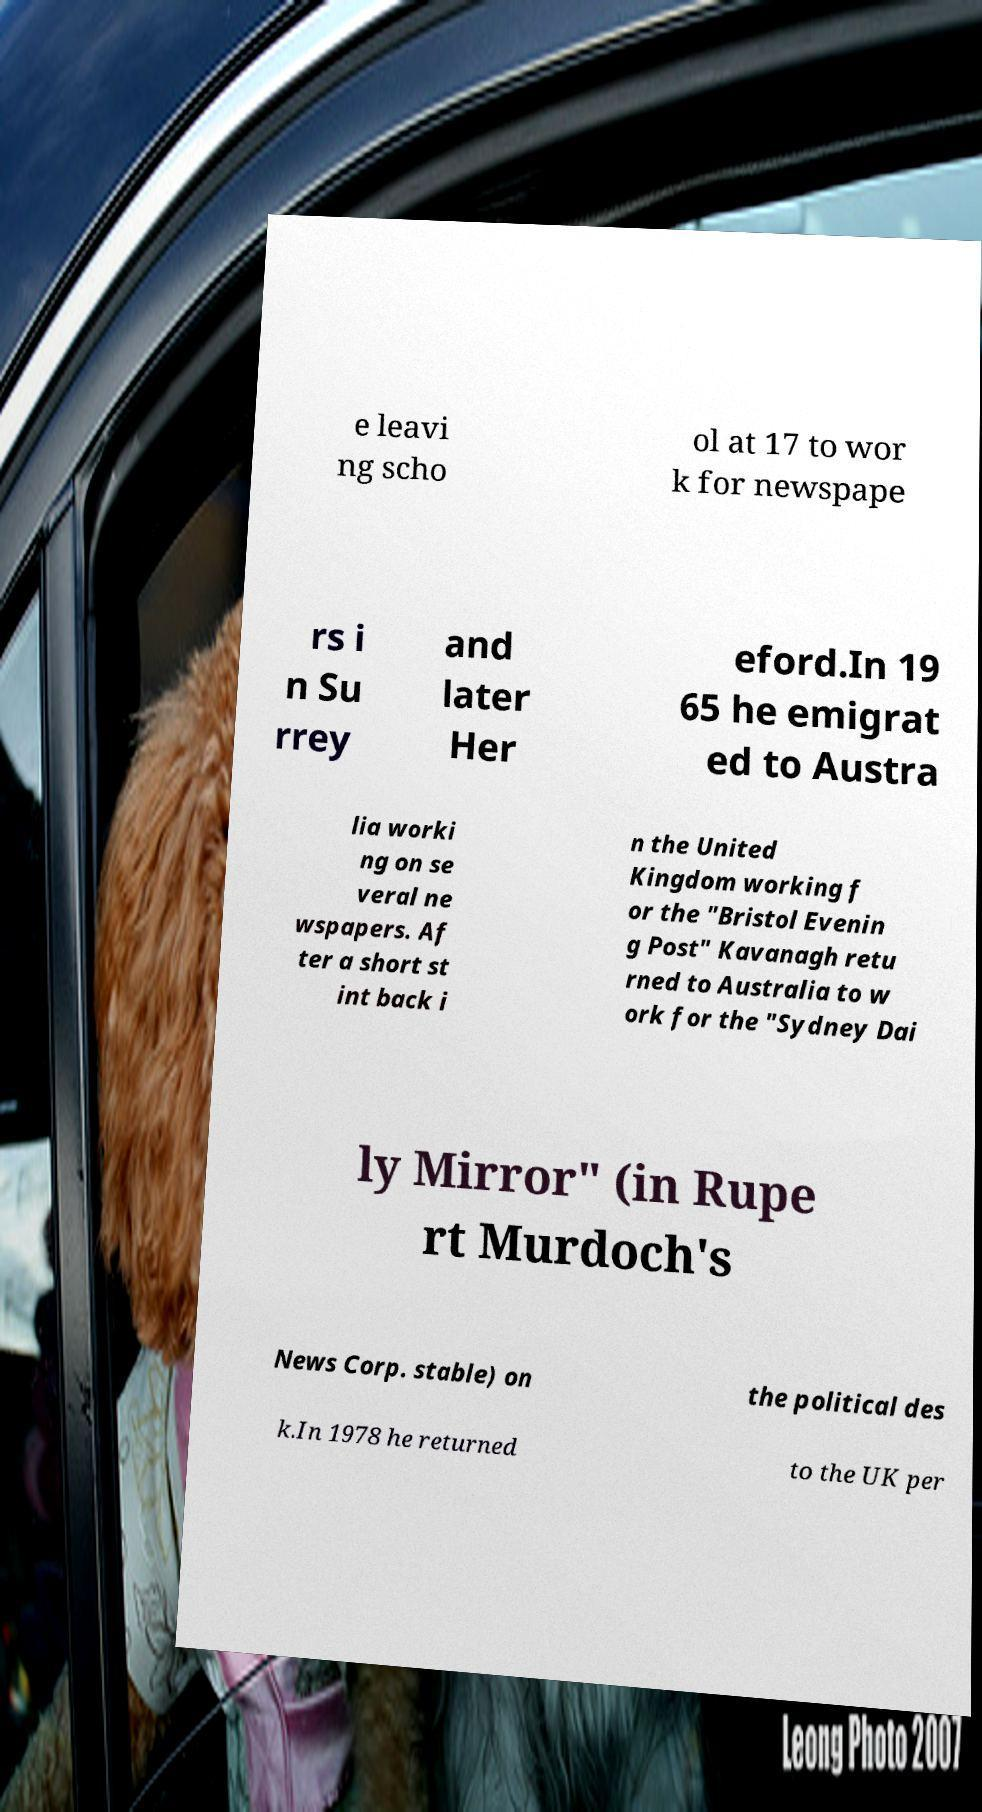I need the written content from this picture converted into text. Can you do that? e leavi ng scho ol at 17 to wor k for newspape rs i n Su rrey and later Her eford.In 19 65 he emigrat ed to Austra lia worki ng on se veral ne wspapers. Af ter a short st int back i n the United Kingdom working f or the "Bristol Evenin g Post" Kavanagh retu rned to Australia to w ork for the "Sydney Dai ly Mirror" (in Rupe rt Murdoch's News Corp. stable) on the political des k.In 1978 he returned to the UK per 